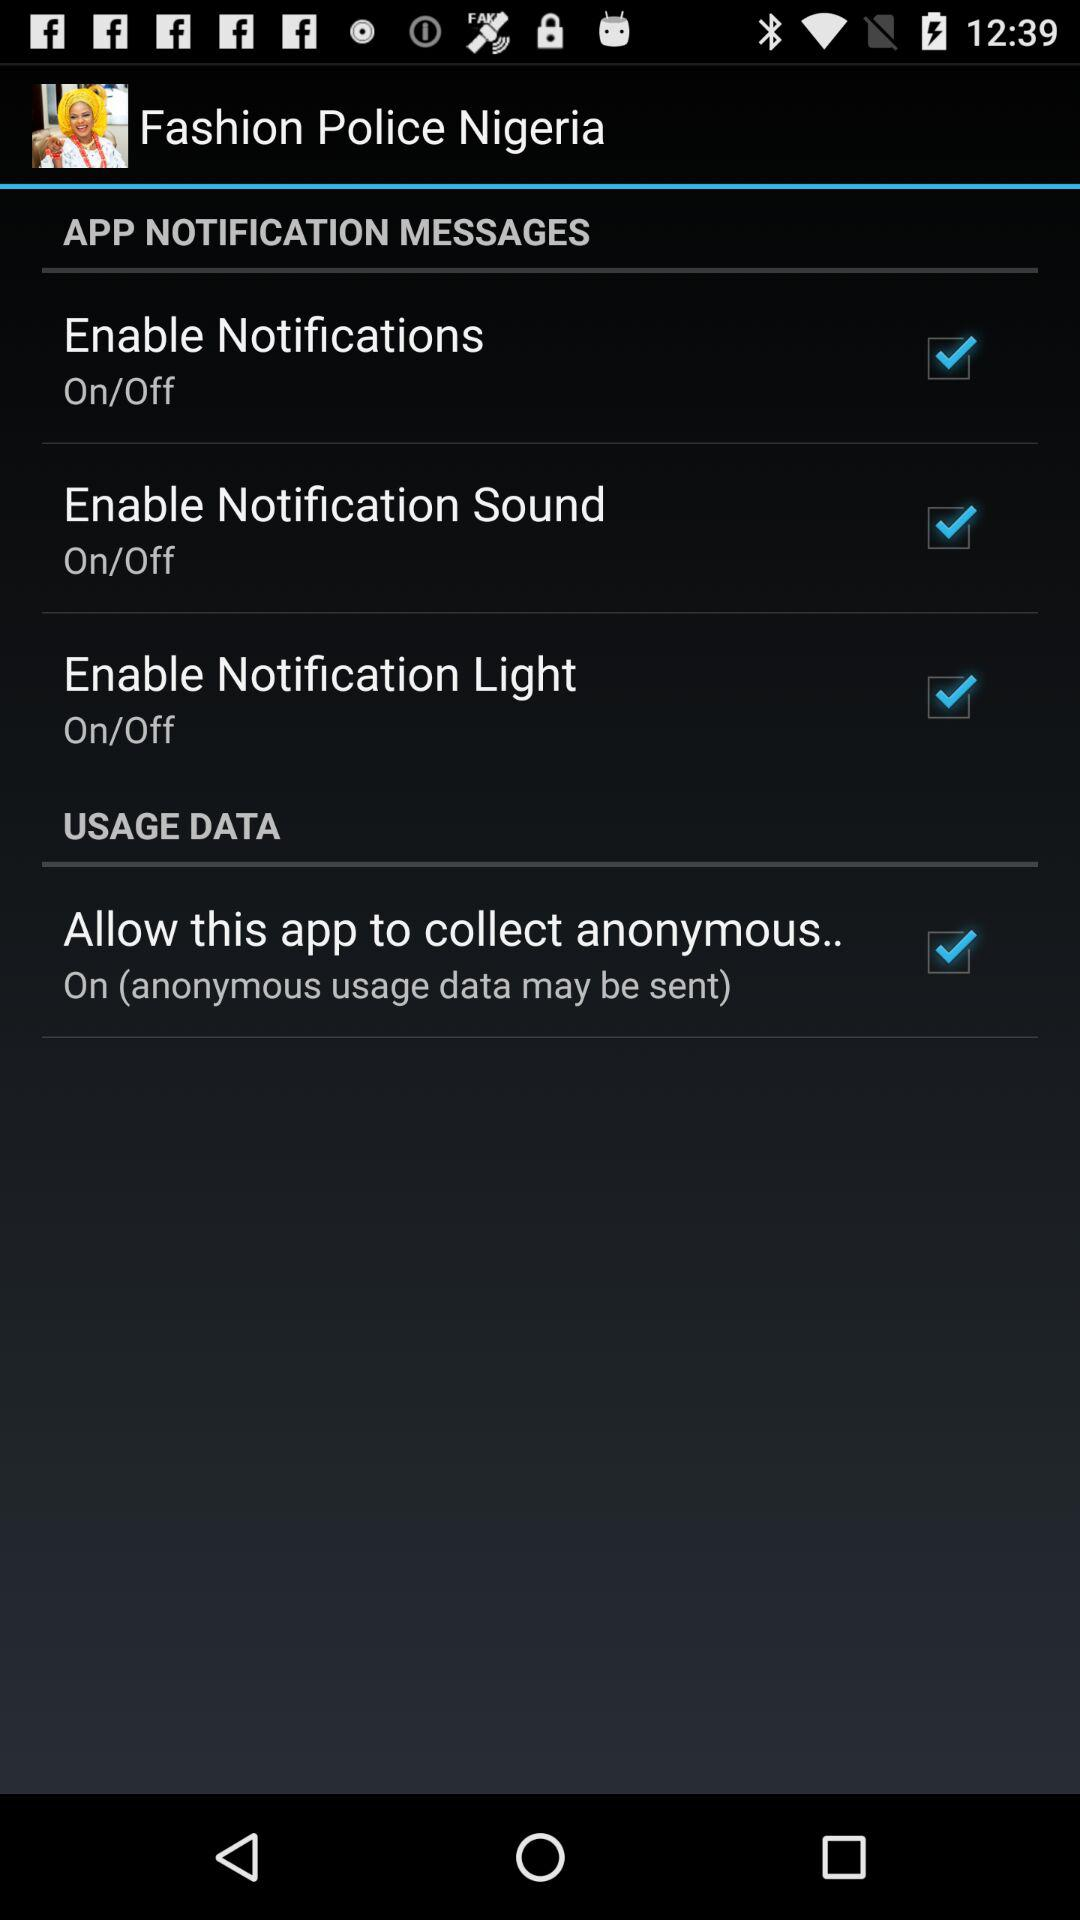What is the current status of "Enable Notification Sound"? The current status of "Enable Notification Sound" is "on". 